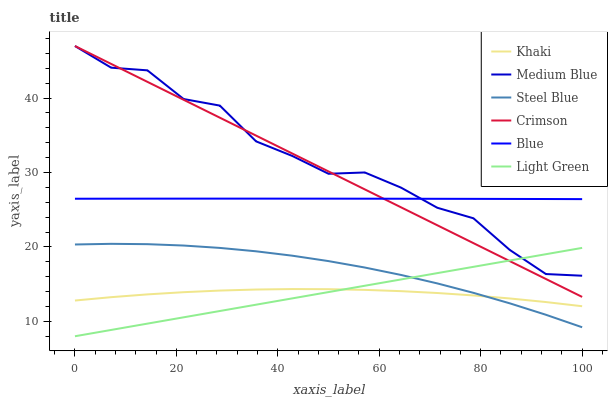Does Medium Blue have the minimum area under the curve?
Answer yes or no. No. Does Khaki have the maximum area under the curve?
Answer yes or no. No. Is Khaki the smoothest?
Answer yes or no. No. Is Khaki the roughest?
Answer yes or no. No. Does Khaki have the lowest value?
Answer yes or no. No. Does Khaki have the highest value?
Answer yes or no. No. Is Steel Blue less than Medium Blue?
Answer yes or no. Yes. Is Blue greater than Steel Blue?
Answer yes or no. Yes. Does Steel Blue intersect Medium Blue?
Answer yes or no. No. 